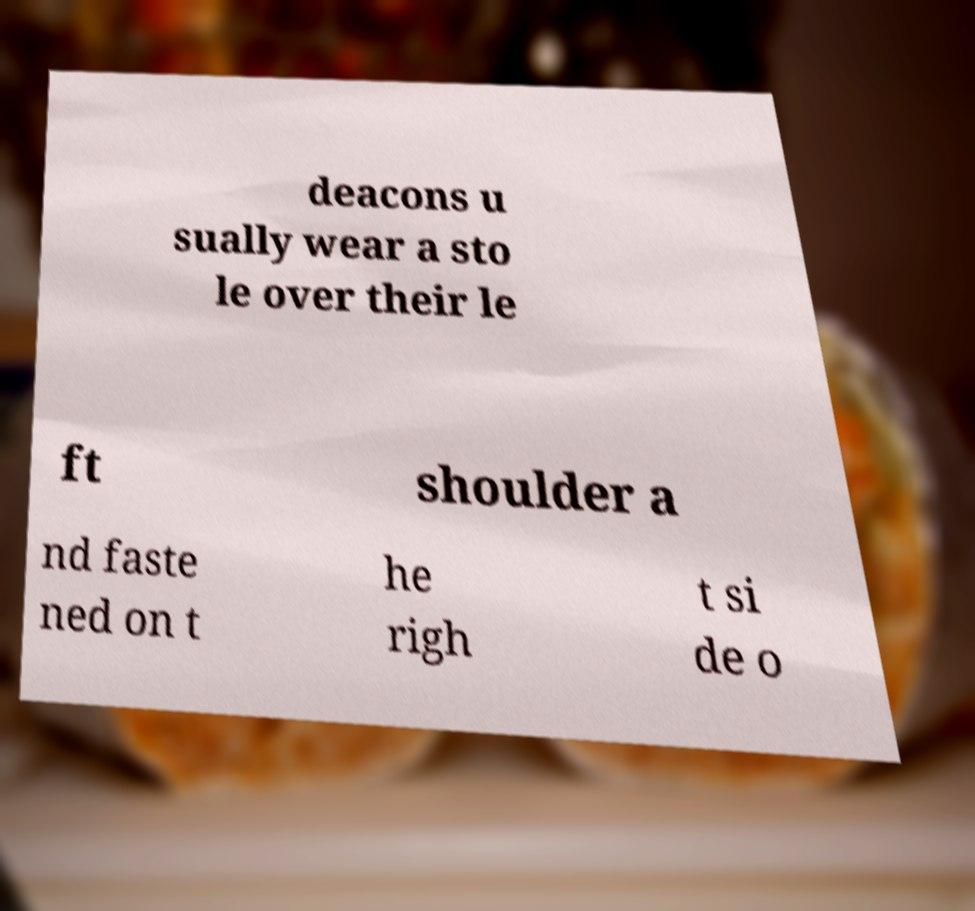Could you extract and type out the text from this image? deacons u sually wear a sto le over their le ft shoulder a nd faste ned on t he righ t si de o 